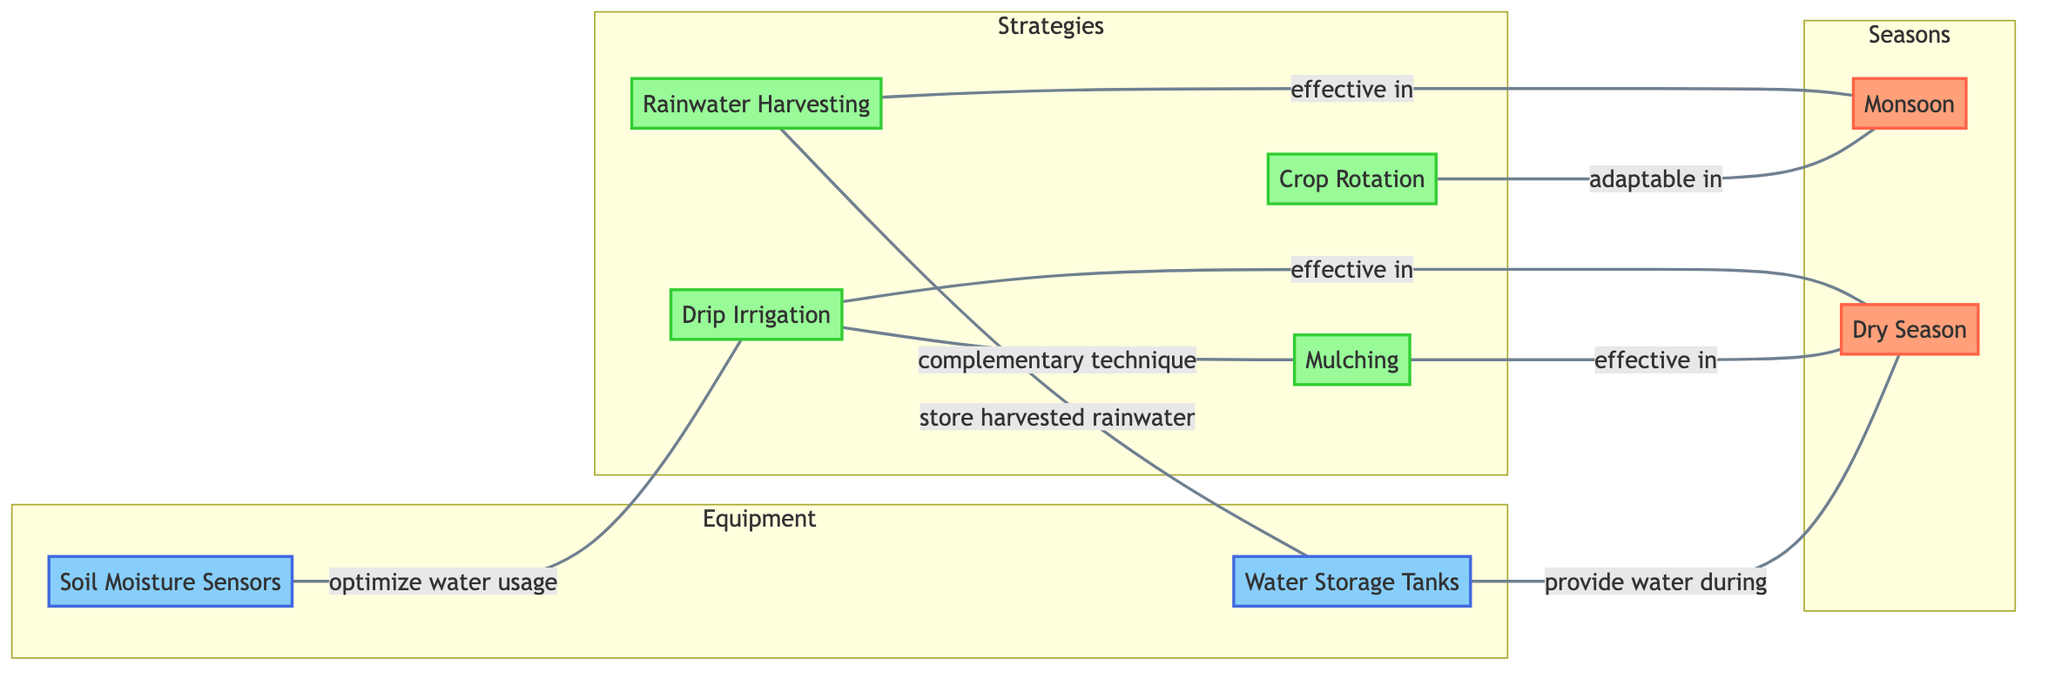What are the two seasons represented in this diagram? The diagram includes two nodes specifically labeled for seasons: "Monsoon" and "Dry Season." These nodes are distinctly classified as part of the "Seasons" subgraph.
Answer: Monsoon, Dry Season Which water management strategy is effective in the Dry Season? The diagram indicates two strategies linked to the Dry Season: "Drip Irrigation" and "Mulching," both marked as effective in this season.
Answer: Drip Irrigation, Mulching How many edges are there in the diagram? Counting the edges listed in the data, there are a total of eight edges connecting various nodes, which represent the relationships between water management strategies and seasons.
Answer: 8 Which strategy is used to optimize water usage? The diagram shows that "Soil Moisture Sensors" are linked to "Drip Irrigation" with the label "optimize water usage," indicating this connection.
Answer: Soil Moisture Sensors What strategy complements Drip Irrigation? The diagram has a link that states "Drip Irrigation" and "Mulching" as a complementary technique, suggesting that these two strategies work together.
Answer: Mulching Which strategy stores harvested rainwater? "Rainwater Harvesting" is connected to the "Water Storage Tanks" with the label "store harvested rainwater," indicating that this strategy is responsible for the storage function.
Answer: Water Storage Tanks In which season is Crop Rotation adaptable? The diagram links "Crop Rotation" to the "Monsoon" season with the label "adaptable in," indicating its usage during this specific season.
Answer: Monsoon What provides water during the Dry Season? The "Water Storage Tanks" are connected to the "Dry Season" with the label "provide water during," highlighting their role in water availability in that season.
Answer: Water Storage Tanks How many strategies are shown in the diagram? There are four strategies represented by nodes: "Rainwater Harvesting," "Drip Irrigation," "Crop Rotation," and "Mulching." Counting these provides the total number of strategies.
Answer: 4 